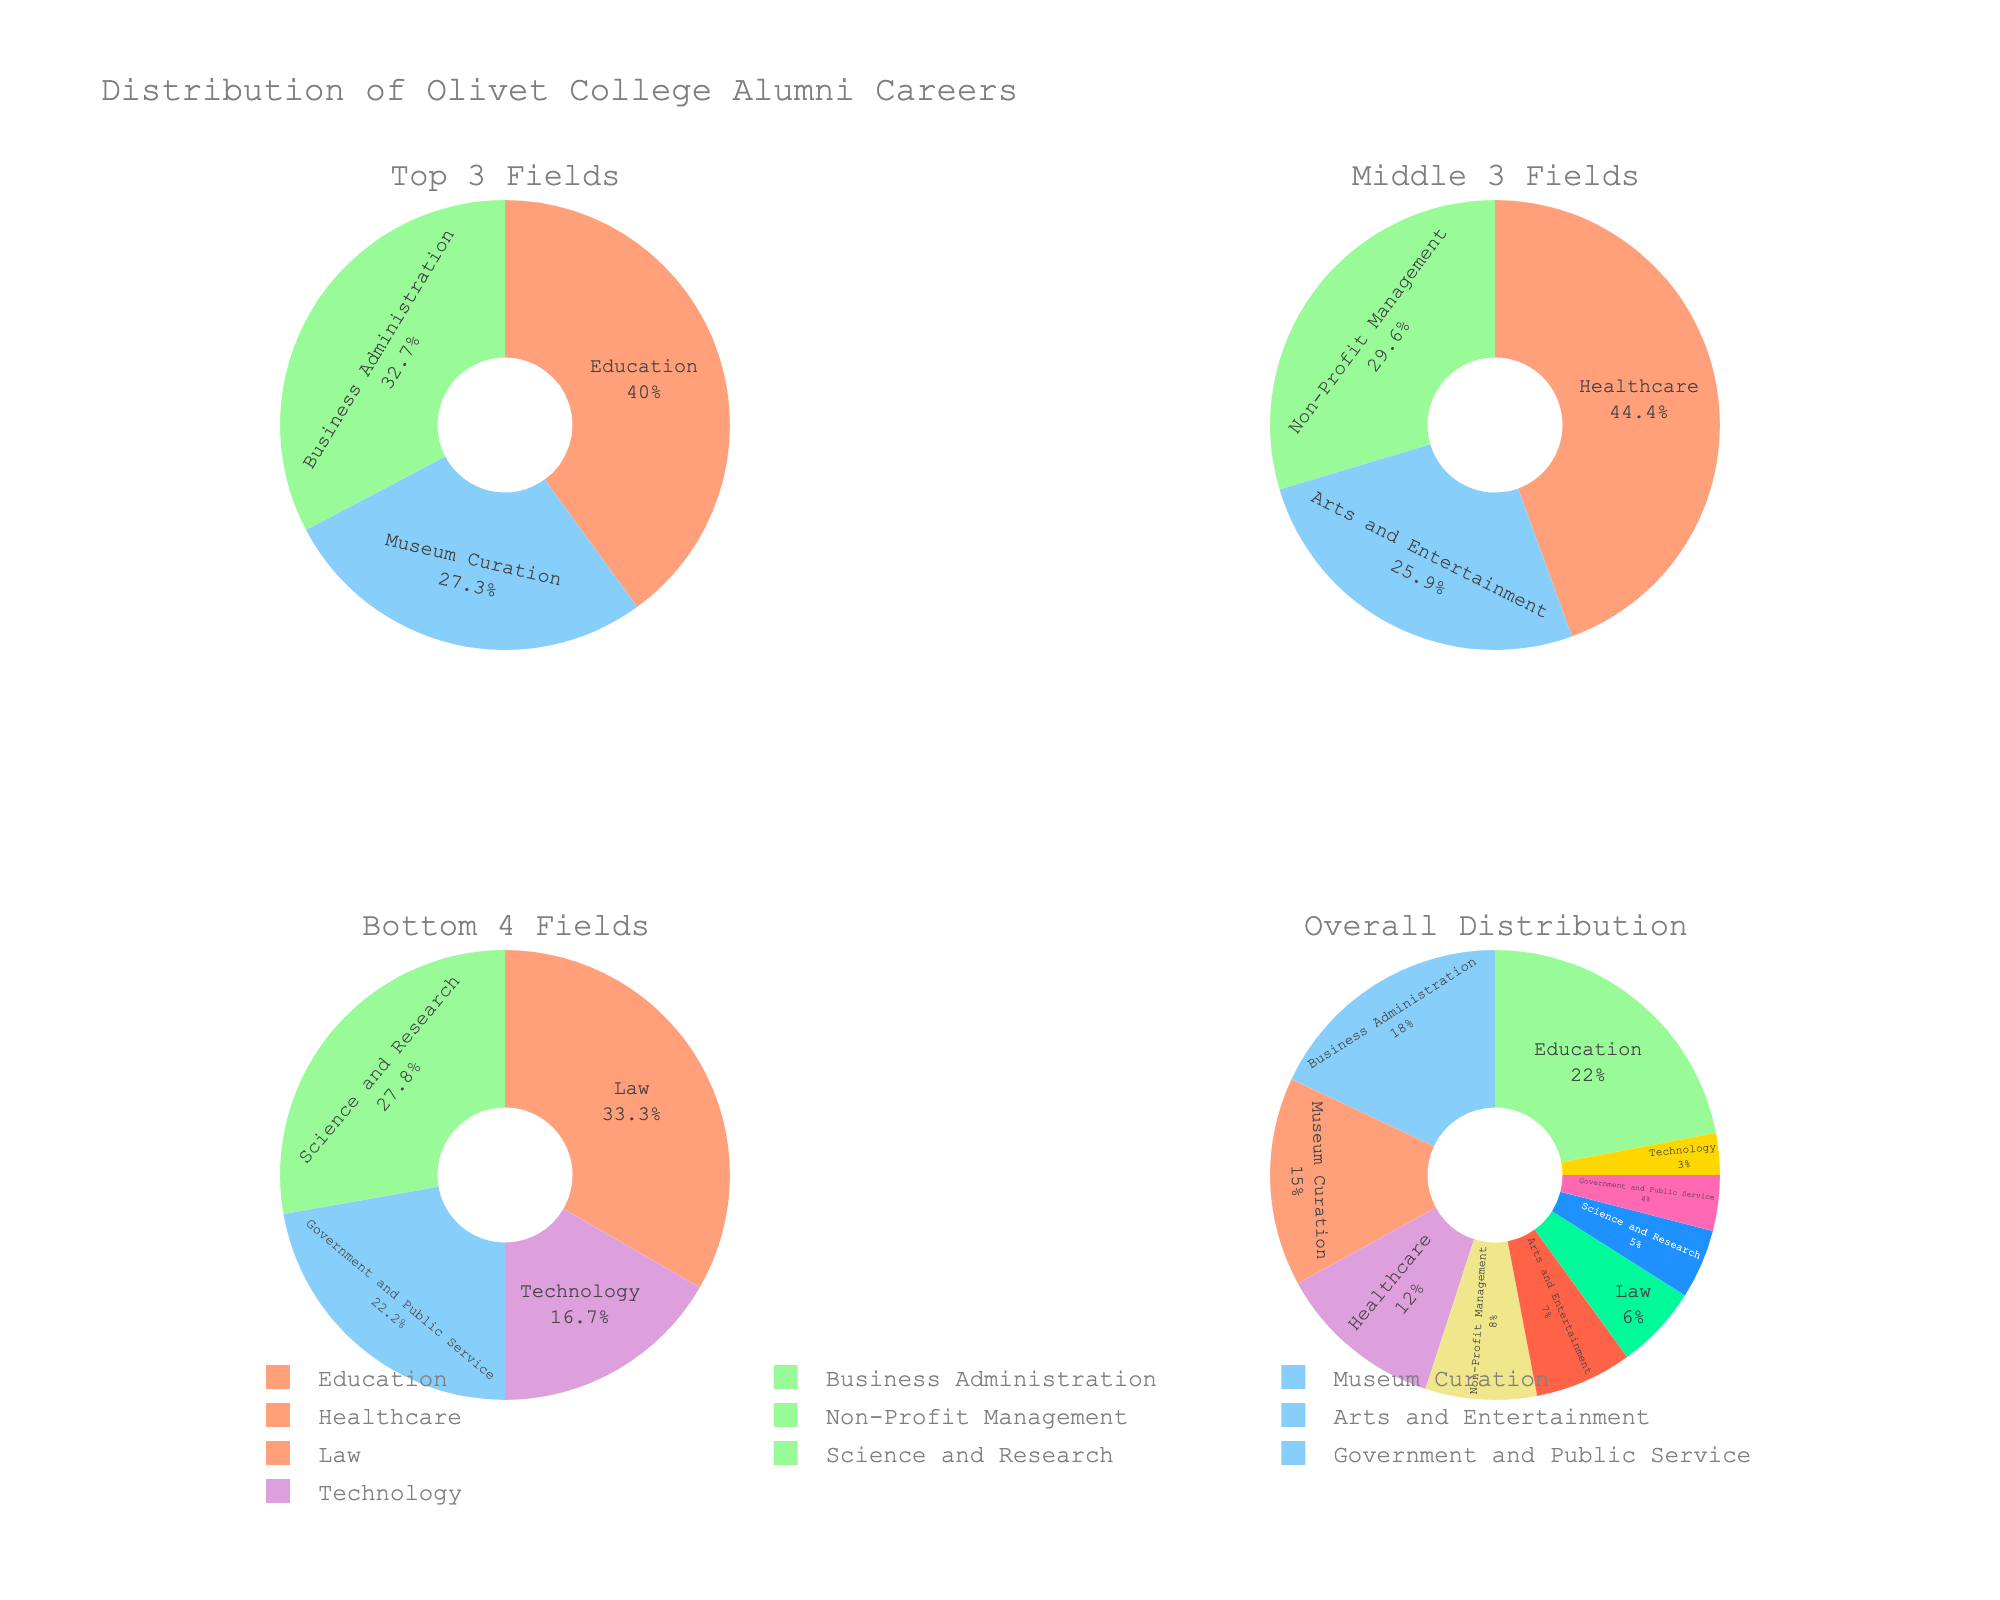How many fields are represented in the overall distribution? The overall distribution shows that there are multiple slices, each representing a field. Counting these slices will give the number of fields.
Answer: 10 Which field has the highest percentage in the top 3 fields plot? The top 3 fields plot is one of the subplots. Look for the slice with the largest area in the first subplot labeled "Top 3 Fields".
Answer: Education What is the combined percentage of Healthcare and Non-Profit Management fields? Locate the percentages for Healthcare and Non-Profit Management from the figure. The figure shows Healthcare at 12% and Non-Profit Management at 8%. Adding these together gives 12% + 8%.
Answer: 20% Which field has the smallest representation in the overall distribution? In the Overall Distribution subplot, look for the smallest slice, which will represent the field with the lowest percentage.
Answer: Technology Compare the percentage of alumni in Education to those in Business Administration. Which is higher, and by how much? Find the percentages for Education and Business Administration in either the top 3 fields or the overall distribution. Education is 22% and Business Administration is 18%. The difference is 22% - 18%.
Answer: Education by 4% What is the total percentage represented by the Middle 3 Fields? The Middle 3 Fields subplot includes percentages for Healthcare, Non-Profit Management, and Arts and Entertainment, which are 12%, 8%, and 7% respectively. Adding these together gives 12% + 8% + 7%.
Answer: 27% In which subplot is Science and Research represented, and what is its percentage? Find Science and Research by locating the field name across the subplots. It is in the Bottom 4 Fields subplot, and its percentage is provided directly.
Answer: Bottom 4 Fields, 5% What percentage of alumni work in Government and Public Service, and how is it represented visually in the figure? Government and Public Service is one of the fields. Look for it in the Overall Distribution subplot and check its percentage directly.
Answer: 4%, represented as a small slice Between the Bottom 4 Fields and the Middle 3 Fields, which group has a higher total percentage and by how much? Calculate the sum of percentages for both groups. The Middle 3 Fields total 27% and the Bottom 4 Fields total 21% (6% + 5% + 4% + 3%). The difference is 27% - 21%.
Answer: Middle 3 by 6% Which field is part of both the Top 3 Fields and the Overall Distribution, and what is its percentage in each? Identify a field present in both the Top 3 Fields plot and the Overall Distribution plot. Education is such a field and has a consistent percentage visible directly.
Answer: Education, 22% 